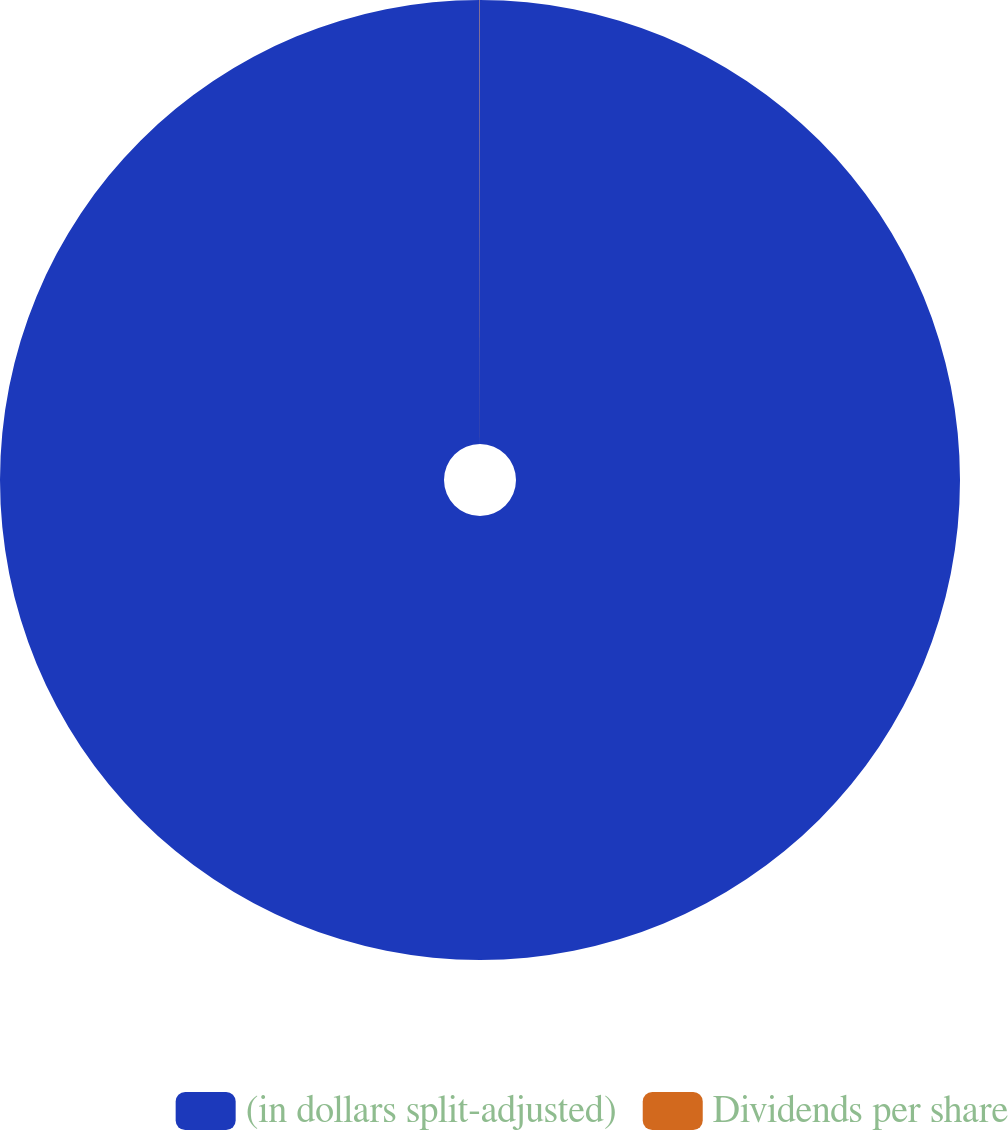Convert chart. <chart><loc_0><loc_0><loc_500><loc_500><pie_chart><fcel>(in dollars split-adjusted)<fcel>Dividends per share<nl><fcel>99.99%<fcel>0.01%<nl></chart> 